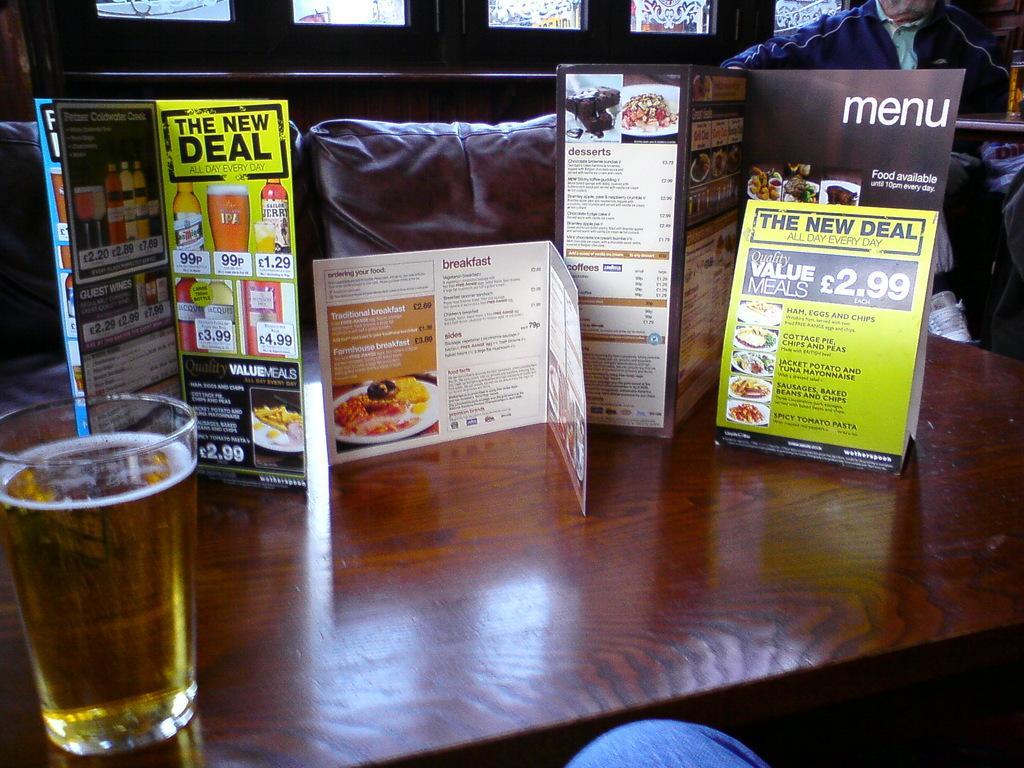Can you describe this image briefly? In this picture I can observe a table in the middle of the picture. I can observe menu cards and a glass placed on the table. 